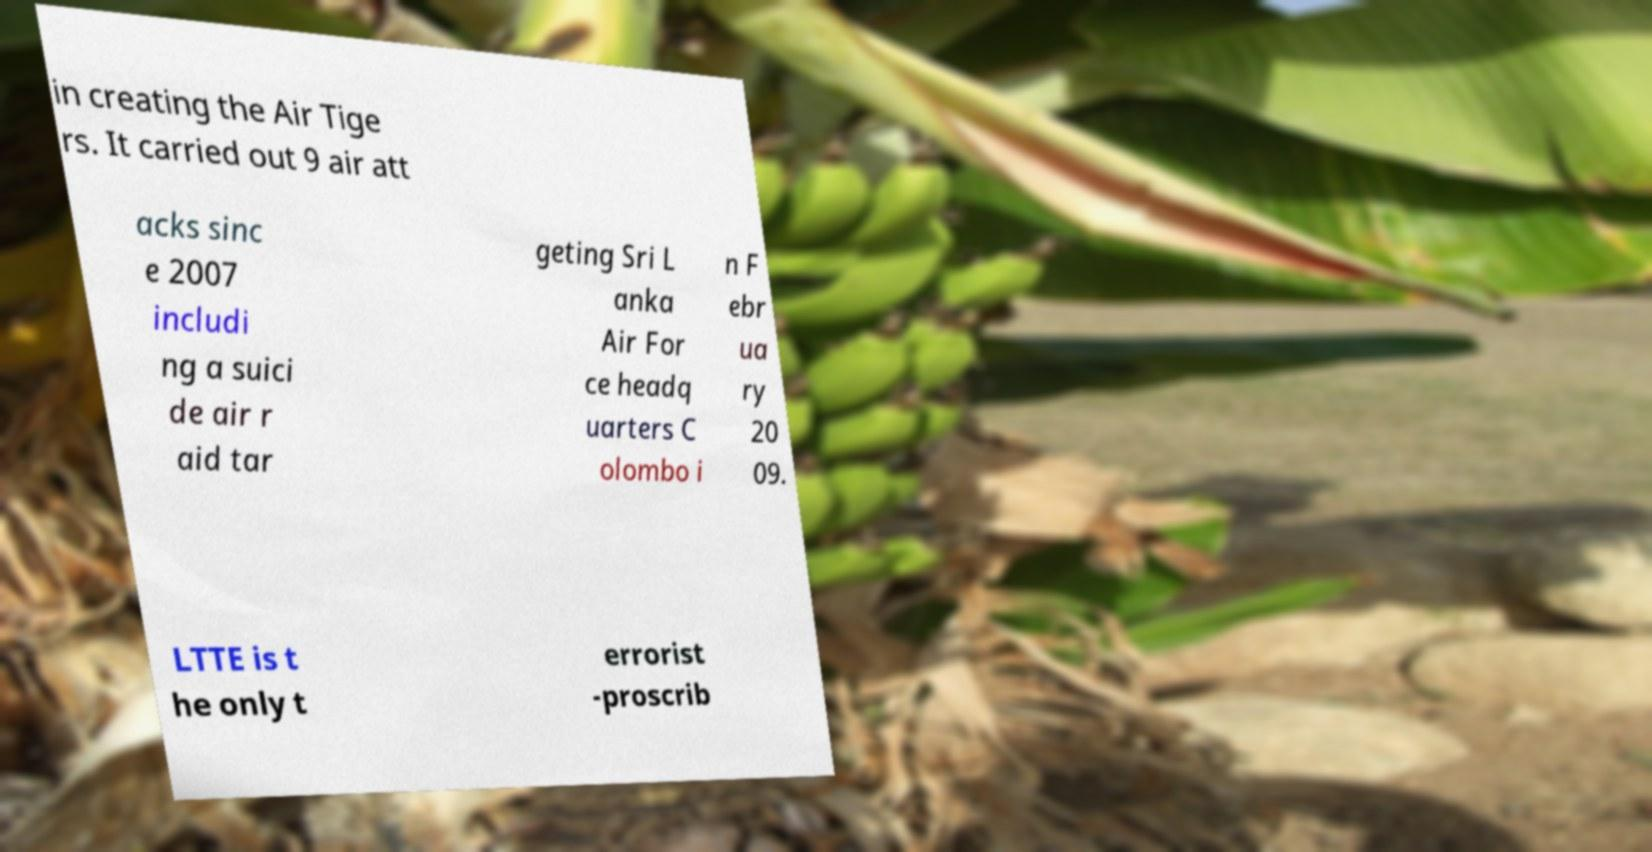What messages or text are displayed in this image? I need them in a readable, typed format. in creating the Air Tige rs. It carried out 9 air att acks sinc e 2007 includi ng a suici de air r aid tar geting Sri L anka Air For ce headq uarters C olombo i n F ebr ua ry 20 09. LTTE is t he only t errorist -proscrib 